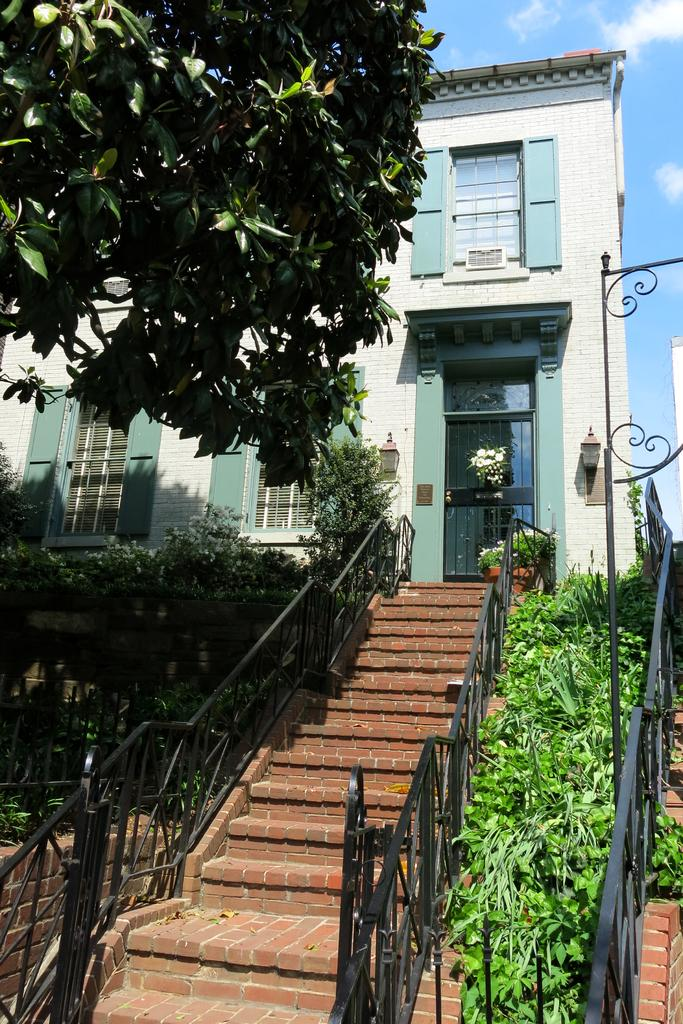What type of structure is visible in the image? There is a building in the image. What features can be seen on the building? The building has windows and a door. Can you describe any objects or elements inside the building? There is a lamp visible in the image. Are there any architectural features present in the image? Yes, there is a staircase in the image. What type of vegetation is present in the image? There are plants and a tree in the image. What is the condition of the sky in the image? The sky looks cloudy in the image. What channel is the building tuned to in the image? There is no indication that the building is tuned to a channel in the image. Can you see any cobwebs in the image? There is no mention of cobwebs in the image, and they are not visible in the provided facts. 